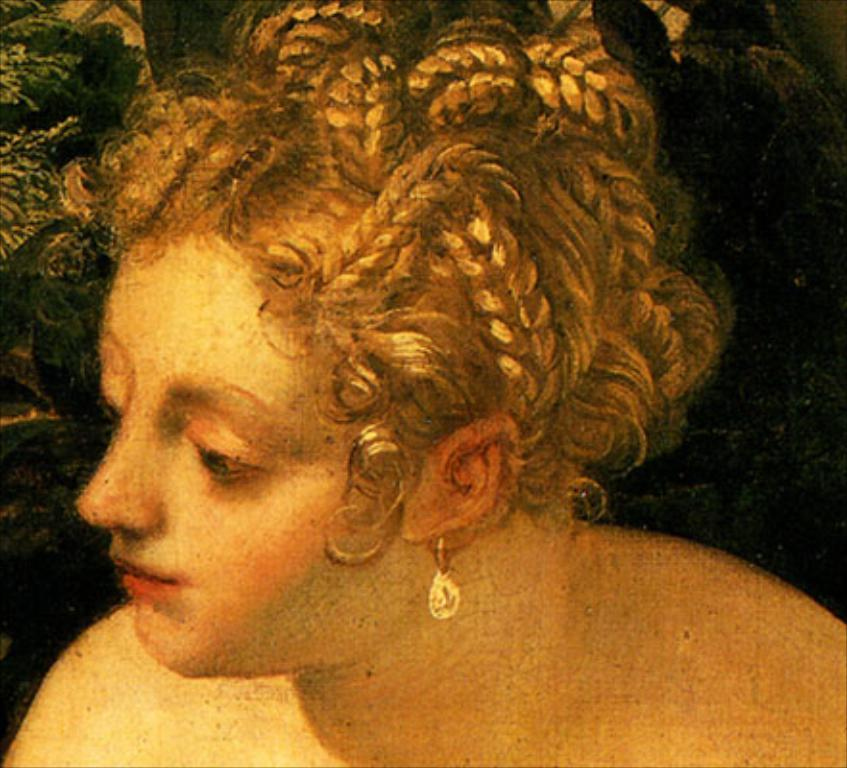What is the main subject of the image? There is a depiction of a person in the image. What type of harmony is being exchanged between the person's eyes in the image? There is no mention of harmony or exchange between the person's eyes in the image. The image only depicts a person, and there is no information about their eyes or any exchange taking place. 